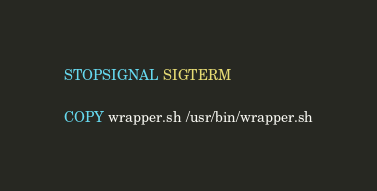Convert code to text. <code><loc_0><loc_0><loc_500><loc_500><_Dockerfile_>STOPSIGNAL SIGTERM

COPY wrapper.sh /usr/bin/wrapper.sh
</code> 